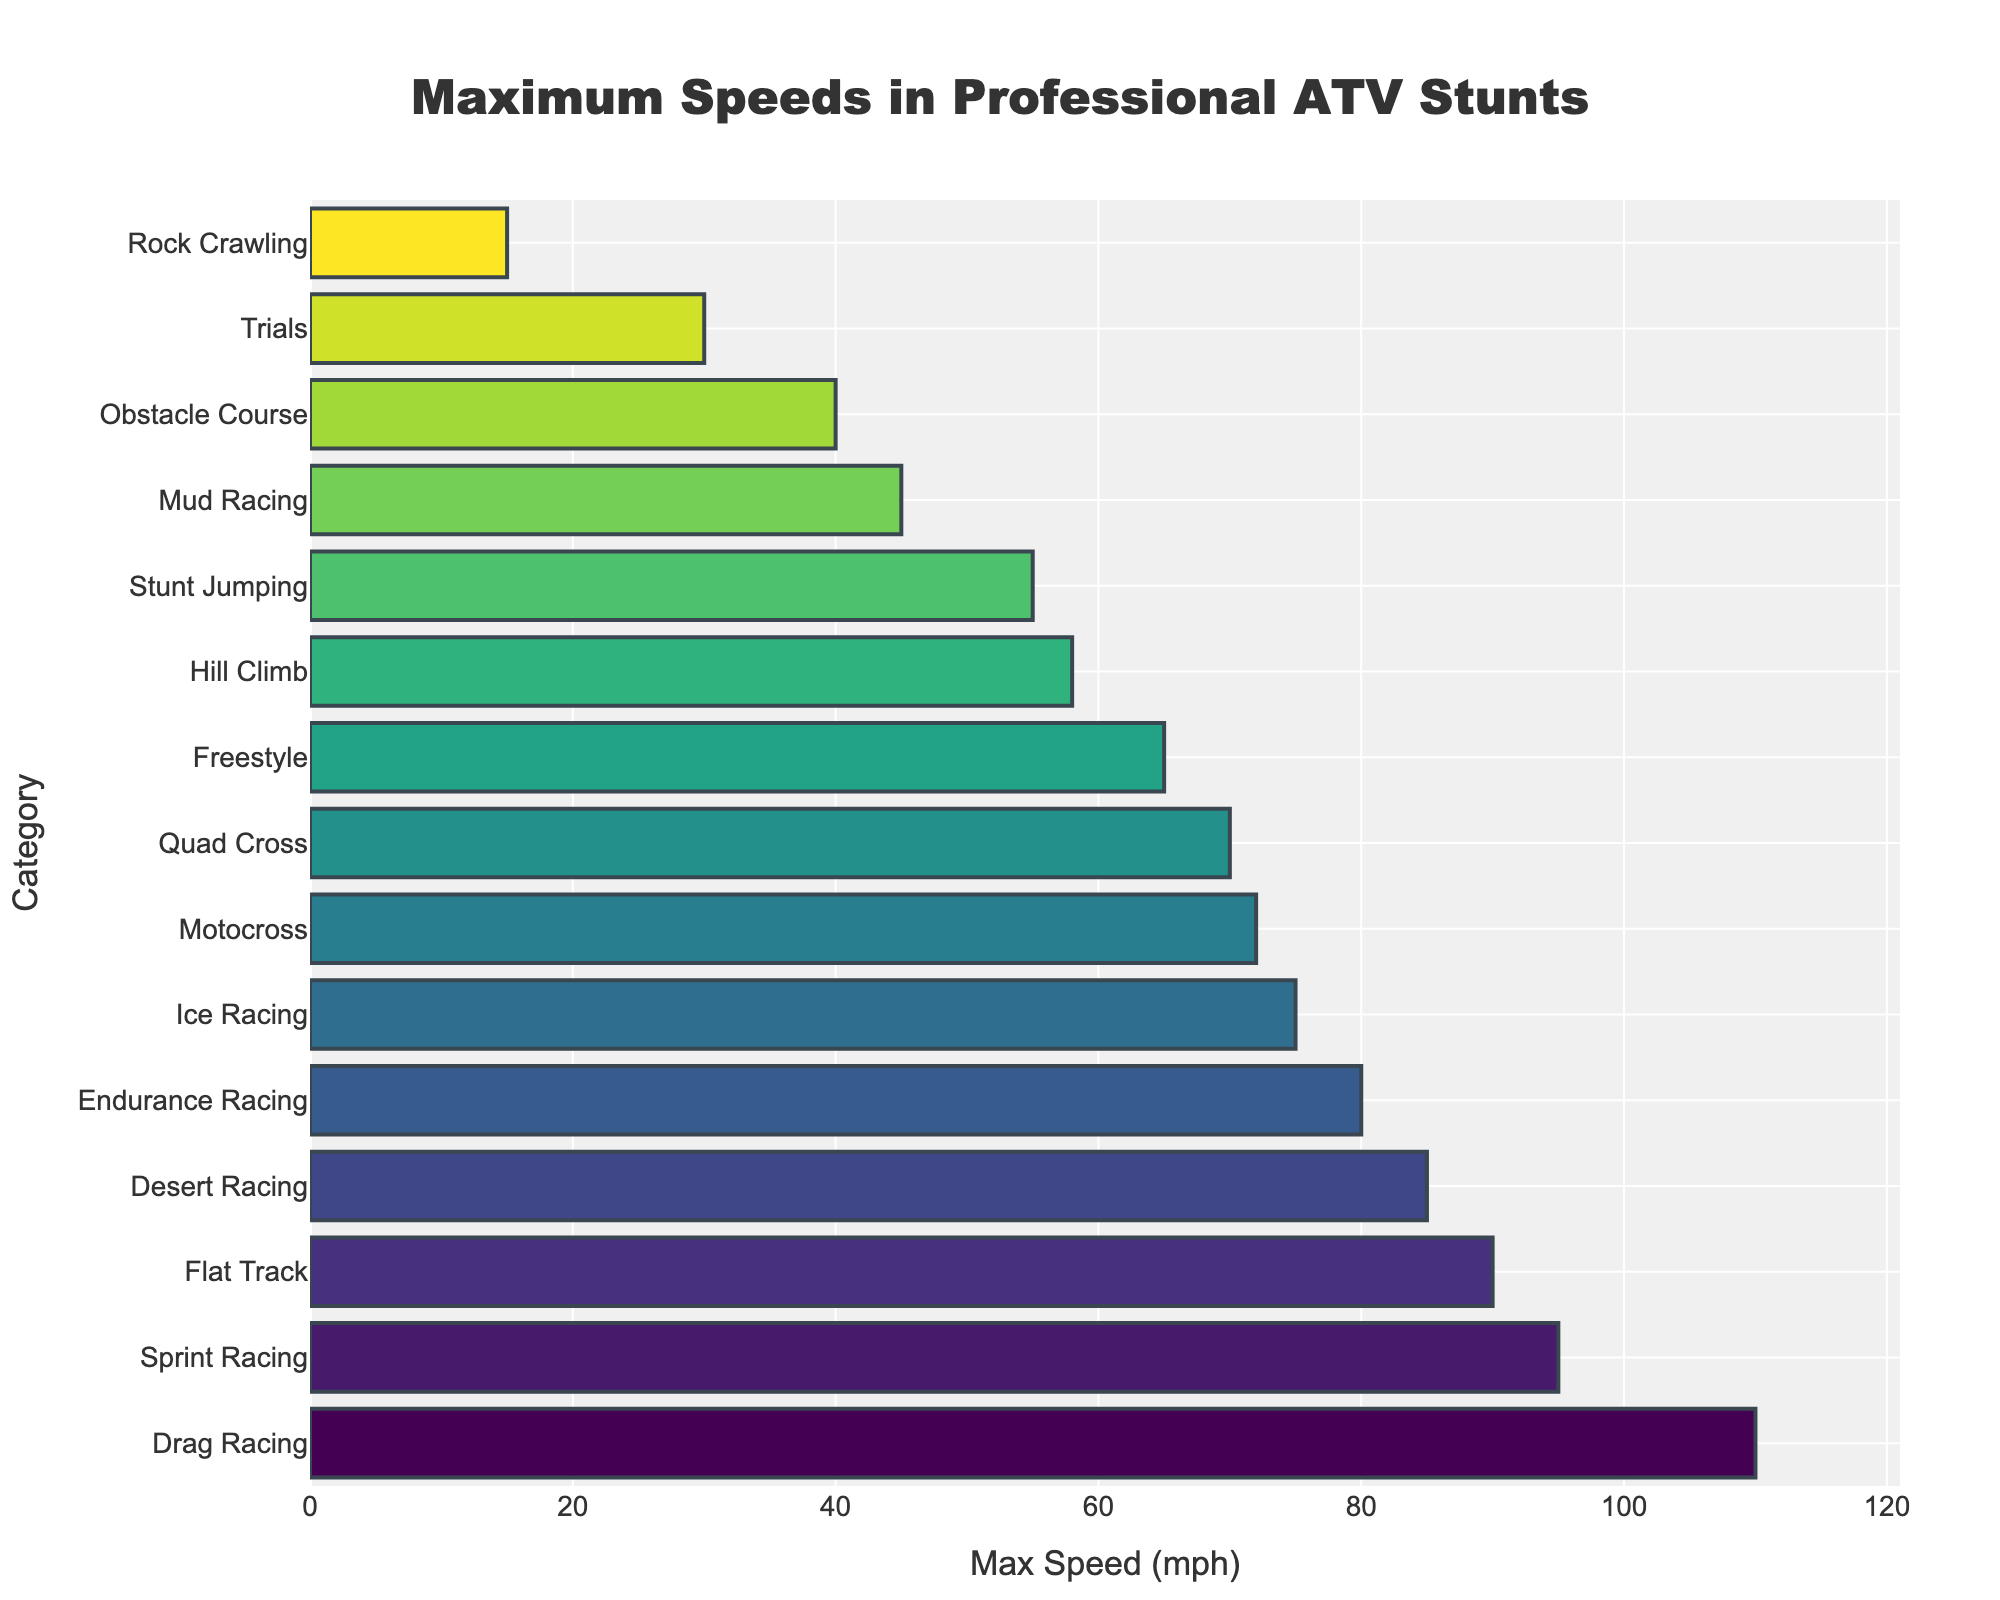Which competition category achieved the highest maximum speed? Identify the bar with the greatest length on the horizontal axis which corresponds to the category with the highest maximum speed.
Answer: Drag Racing How much faster is Flat Track compared to Freestyle? Subtract the maximum speed of Freestyle (65 mph) from that of Flat Track (90 mph).
Answer: 25 mph What's the median speed among all categories? First, list all speed values in ascending order: 15, 30, 40, 45, 55, 58, 65, 70, 72, 75, 80, 85, 90, 95, 110. The median value is the middle number, which is the 8th value.
Answer: 70 mph Which categories have a maximum speed greater than 85 mph? Identify categories with bars extending beyond the 85 mph mark.
Answer: Drag Racing, Flat Track, Sprint Racing What is the combined maximum speed of Endurance Racing and Desert Racing? Add the maximum speed of Endurance Racing (80 mph) and Desert Racing (85 mph).
Answer: 165 mph How much lower is the speed of Rock Crawling than Mud Racing? Subtract the maximum speed of Rock Crawling (15 mph) from that of Mud Racing (45 mph).
Answer: 30 mph Identify the competition categories with a maximum speed less than 50 mph. Identify bars that do not extend beyond the 50 mph mark.
Answer: Rock Crawling, Mud Racing, Trials, Obstacle Course How do the speeds of Stunt Jumping and Hill Climb compare? Compare the bar lengths of Stunt Jumping (55 mph) and Hill Climb (58 mph). Hill Climb is faster by 3 mph.
Answer: Hill Climb is faster by 3 mph 